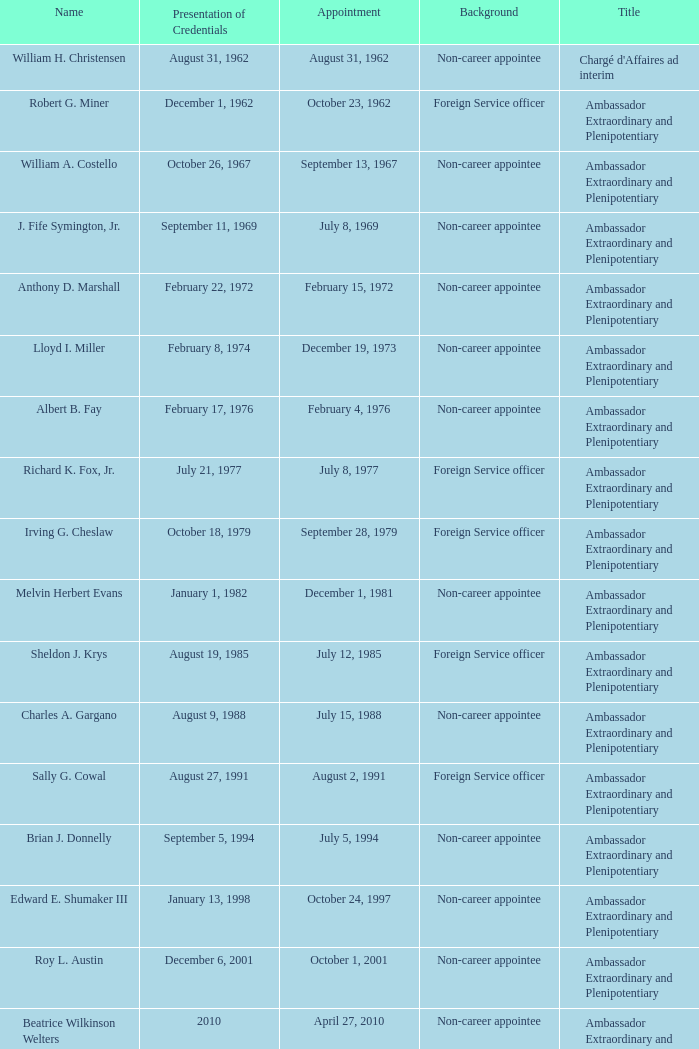What was Anthony D. Marshall's title? Ambassador Extraordinary and Plenipotentiary. 